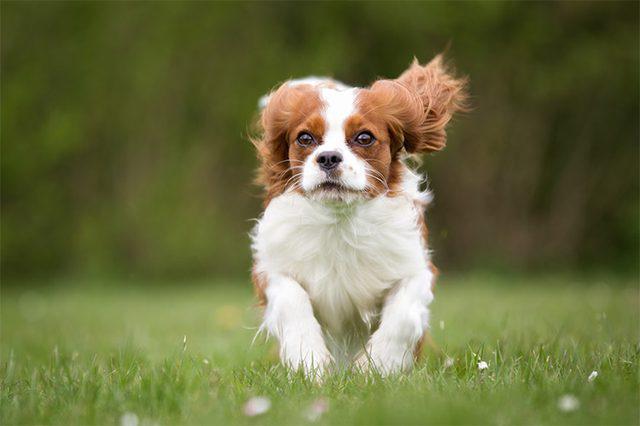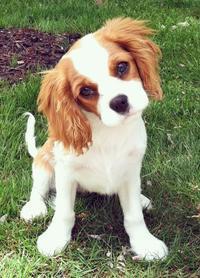The first image is the image on the left, the second image is the image on the right. Examine the images to the left and right. Is the description "In one image, there is one brown and white dog and one black, white and brown dog sitting side by side outdoors while staring straight ahead at the camera" accurate? Answer yes or no. No. The first image is the image on the left, the second image is the image on the right. Examine the images to the left and right. Is the description "An image shows a horizontal row of four different-colored dogs sitting on the grass." accurate? Answer yes or no. No. 